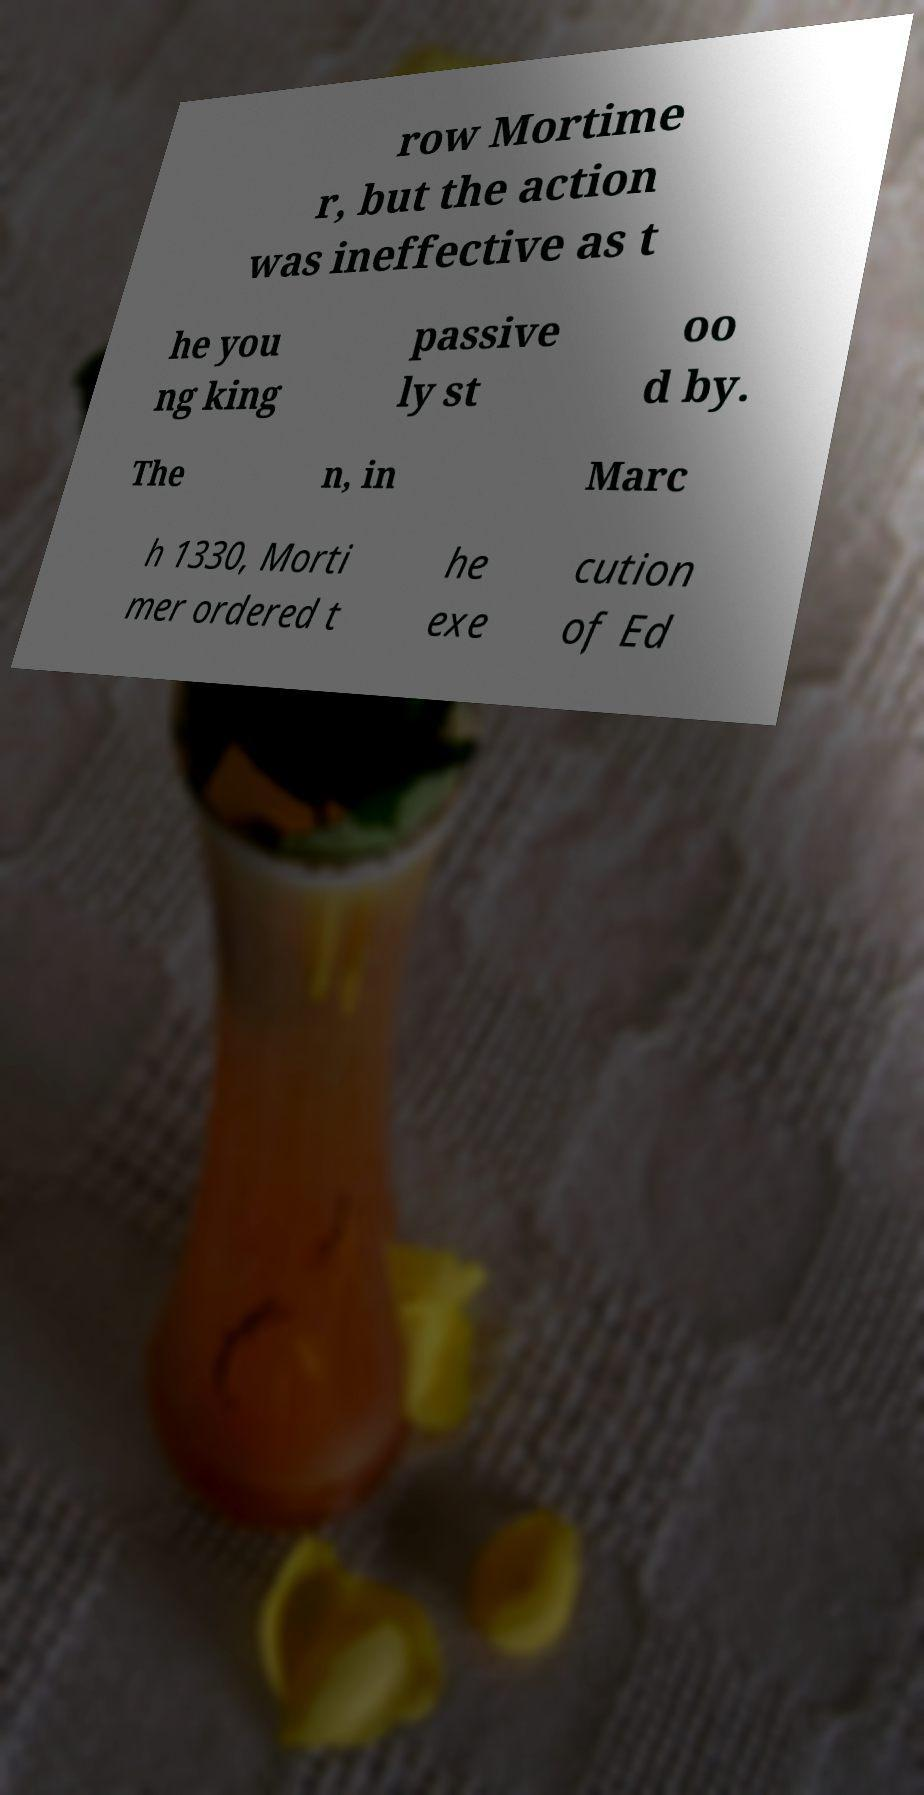What messages or text are displayed in this image? I need them in a readable, typed format. row Mortime r, but the action was ineffective as t he you ng king passive ly st oo d by. The n, in Marc h 1330, Morti mer ordered t he exe cution of Ed 